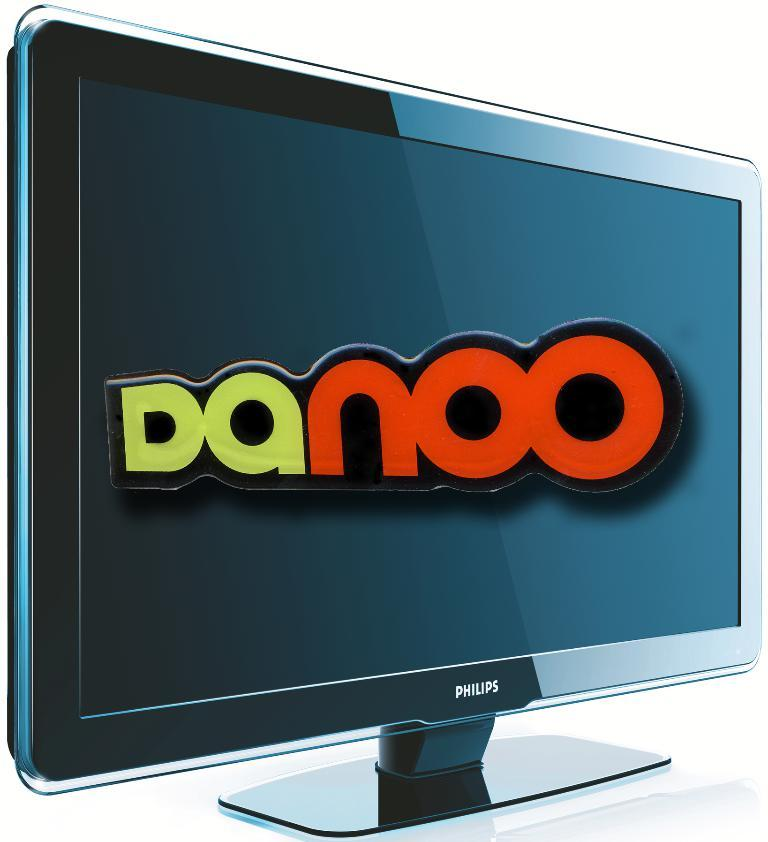What is displayed on the screen in the image? There is a screen with text in the image. What color is the background of the image? The background of the image is white. How many balls are being juggled by the man in the image? There is no man or balls present in the image; it only features a screen with text and a white background. 